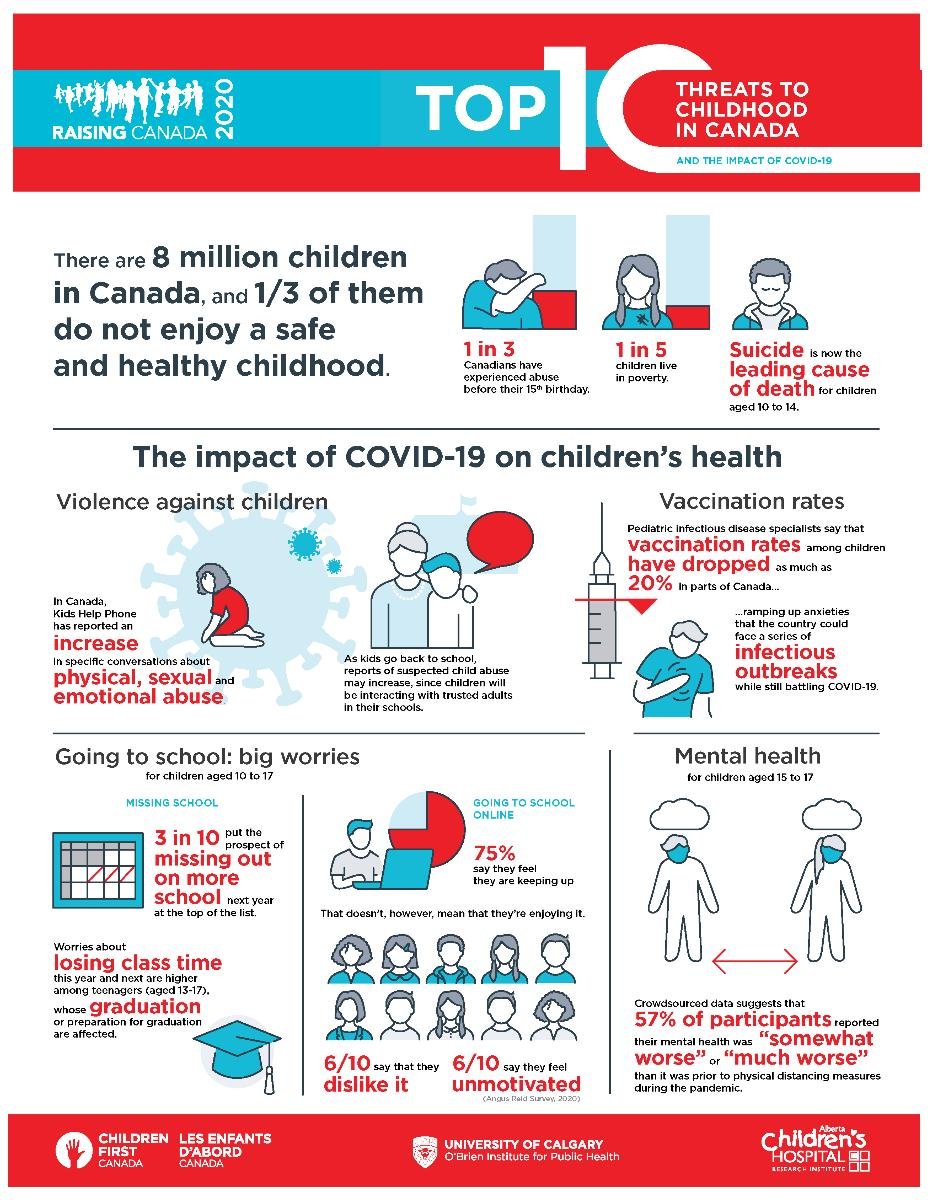Outline some significant characteristics in this image. According to recent data, only 25% of Canadian students are not attending classes online. 1 in 3 children were misused before reaching the age of 15," according to recent statistics. If a sample of 3 is taken, approximately 67% of children in Canada have had a happy childhood. Out of the 10 children sampled, 6 of them reported that they are lazy to attend online classes. The majority of Canadian students, approximately 75%, are enrolled in online classes. 